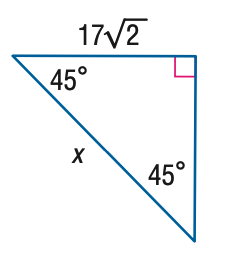Answer the mathemtical geometry problem and directly provide the correct option letter.
Question: Find x.
Choices: A: 17 B: 17 \sqrt { 2 } C: 34 D: 17 \sqrt { 6 } C 